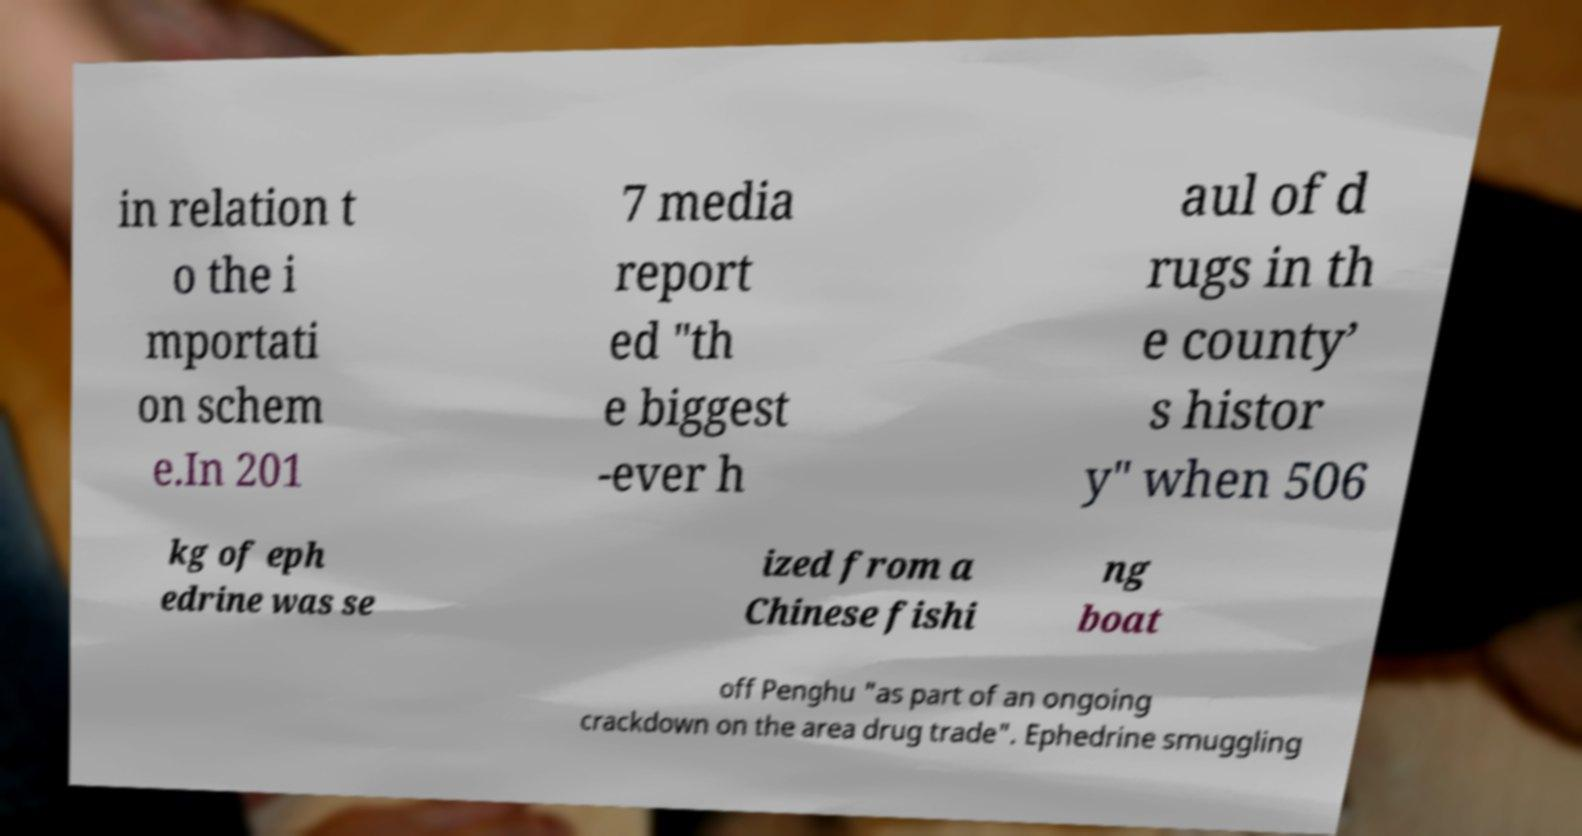Can you read and provide the text displayed in the image?This photo seems to have some interesting text. Can you extract and type it out for me? in relation t o the i mportati on schem e.In 201 7 media report ed "th e biggest -ever h aul of d rugs in th e county’ s histor y" when 506 kg of eph edrine was se ized from a Chinese fishi ng boat off Penghu "as part of an ongoing crackdown on the area drug trade". Ephedrine smuggling 